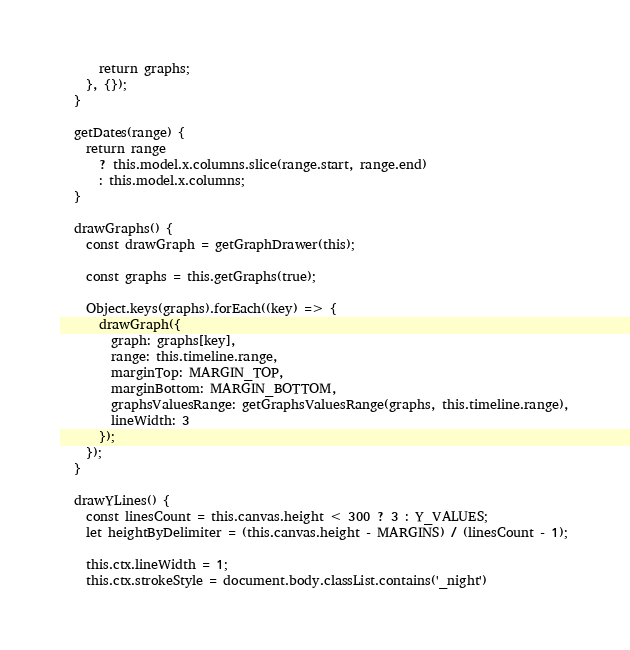<code> <loc_0><loc_0><loc_500><loc_500><_JavaScript_>
      return graphs;
    }, {});
  }

  getDates(range) {
    return range
      ? this.model.x.columns.slice(range.start, range.end)
      : this.model.x.columns;
  }

  drawGraphs() {
    const drawGraph = getGraphDrawer(this);

    const graphs = this.getGraphs(true);

    Object.keys(graphs).forEach((key) => {
      drawGraph({
        graph: graphs[key],
        range: this.timeline.range,
        marginTop: MARGIN_TOP,
        marginBottom: MARGIN_BOTTOM,
        graphsValuesRange: getGraphsValuesRange(graphs, this.timeline.range),
        lineWidth: 3
      });
    });
  }

  drawYLines() {
    const linesCount = this.canvas.height < 300 ? 3 : Y_VALUES;
    let heightByDelimiter = (this.canvas.height - MARGINS) / (linesCount - 1);

    this.ctx.lineWidth = 1;
    this.ctx.strokeStyle = document.body.classList.contains('_night')</code> 